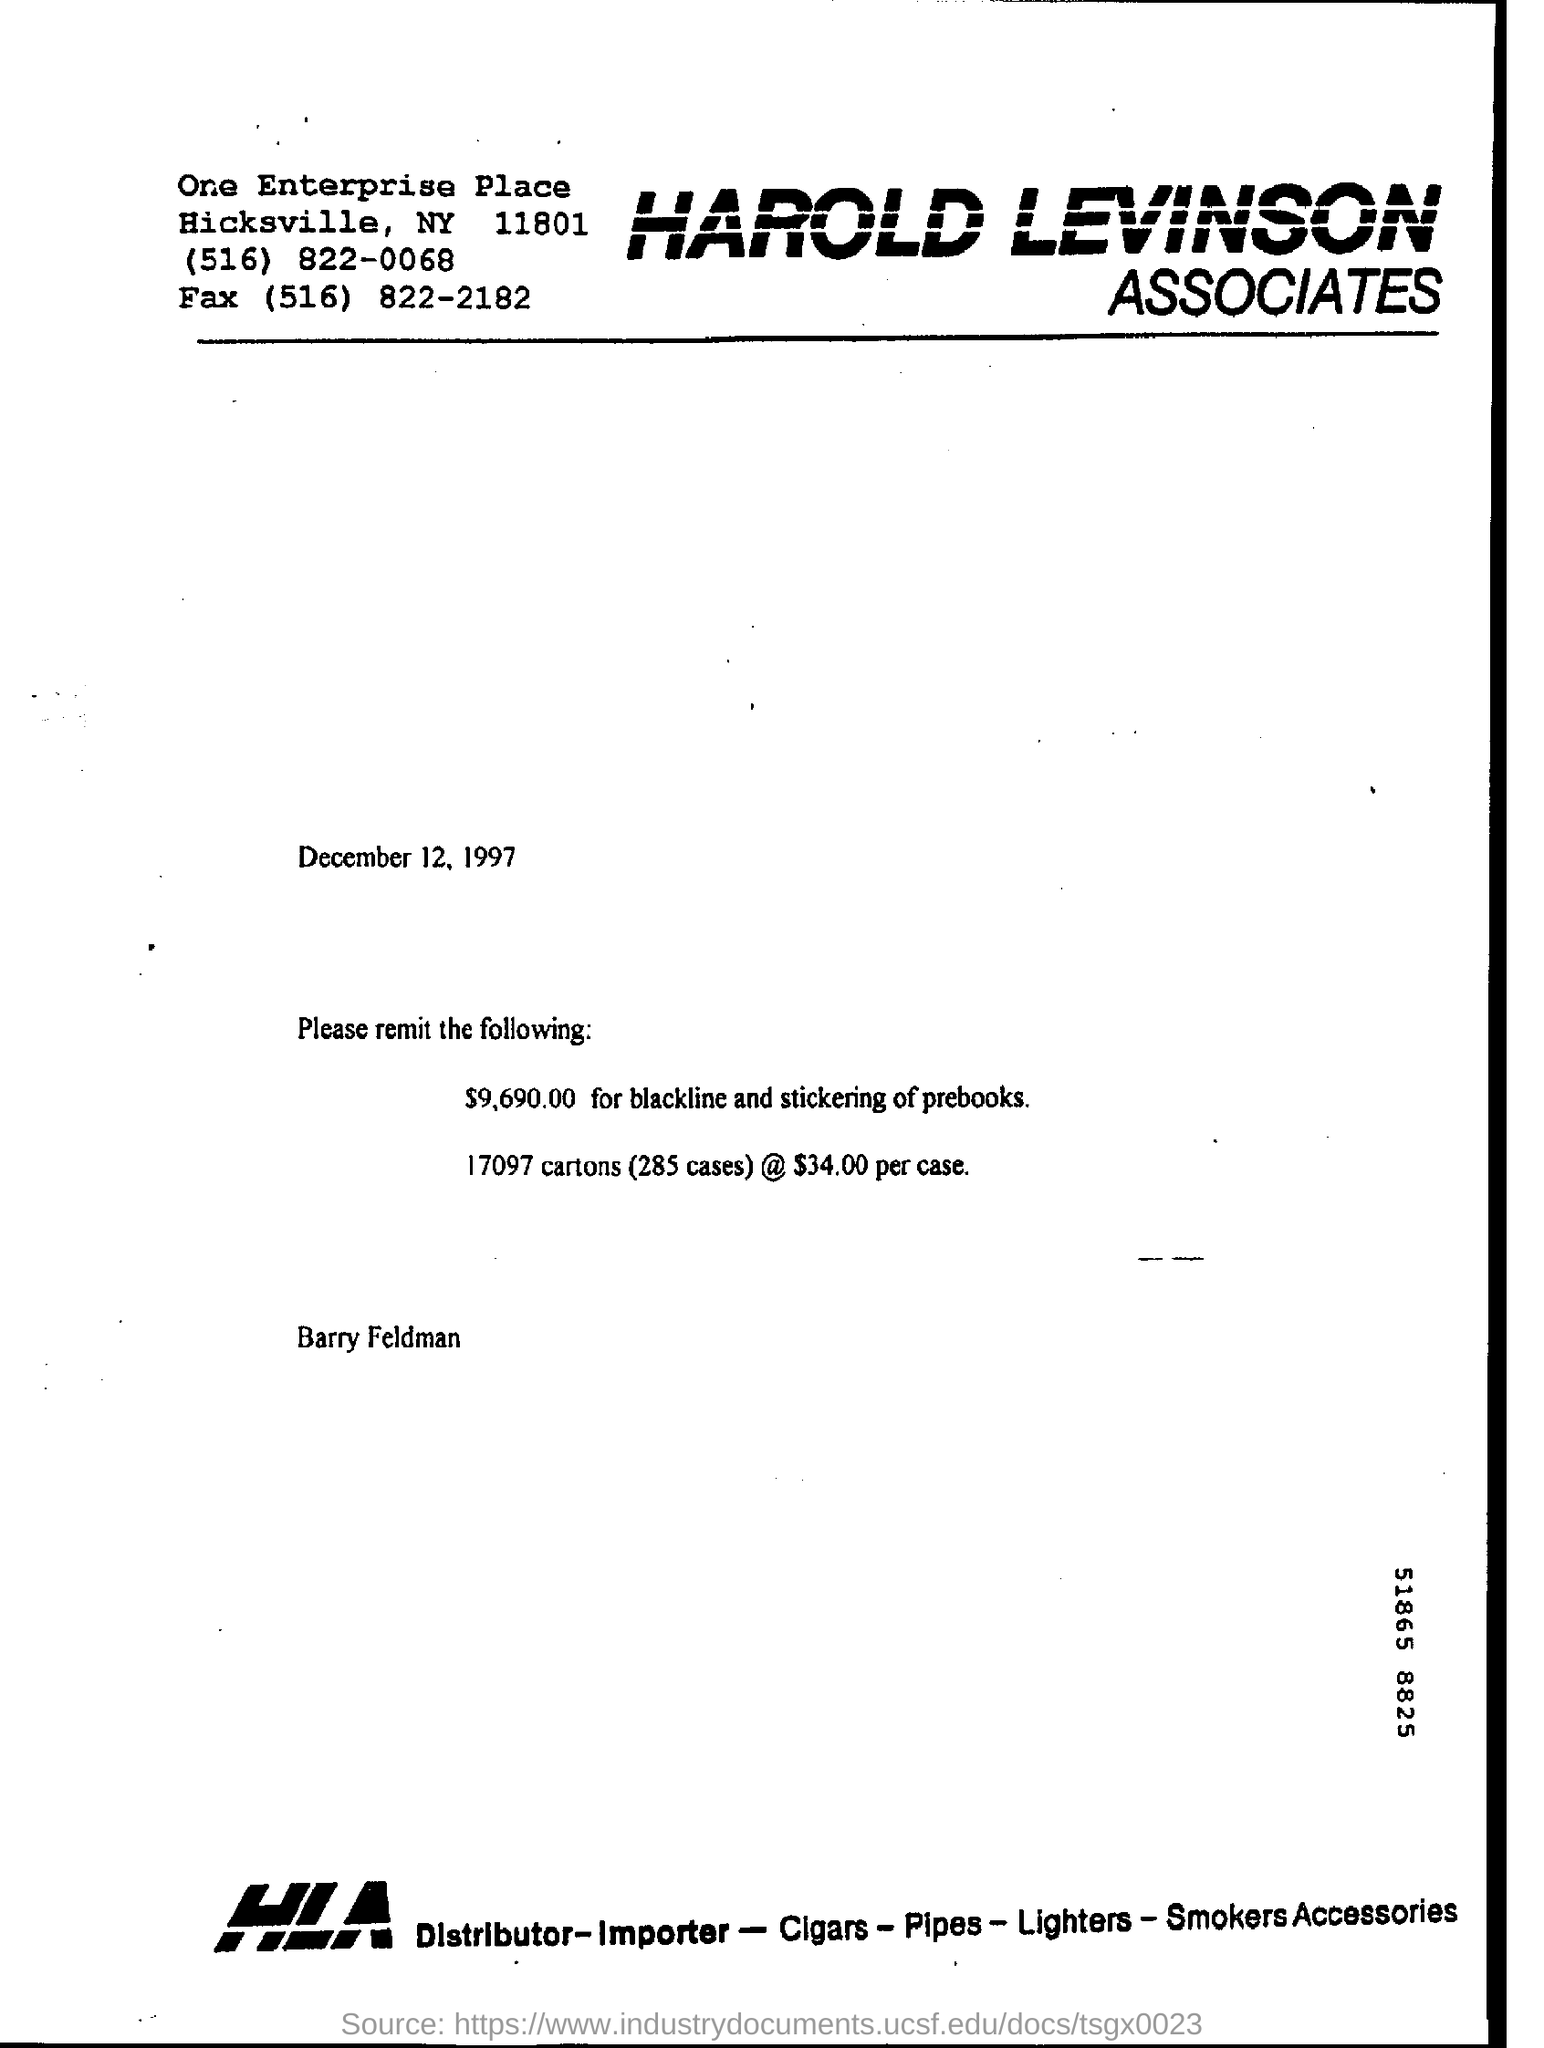Give some essential details in this illustration. The black line and stickering of prebooks has cost a total of $9,690.00. The acronym "HLA" stands for "Harold Levinson Associates. 